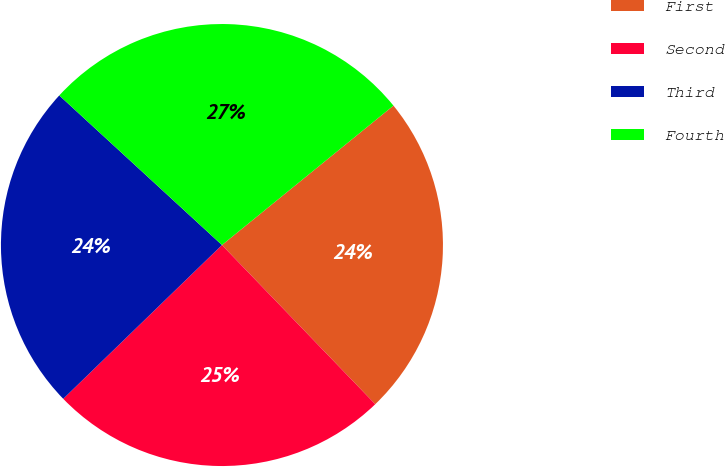Convert chart to OTSL. <chart><loc_0><loc_0><loc_500><loc_500><pie_chart><fcel>First<fcel>Second<fcel>Third<fcel>Fourth<nl><fcel>23.66%<fcel>24.95%<fcel>24.08%<fcel>27.3%<nl></chart> 